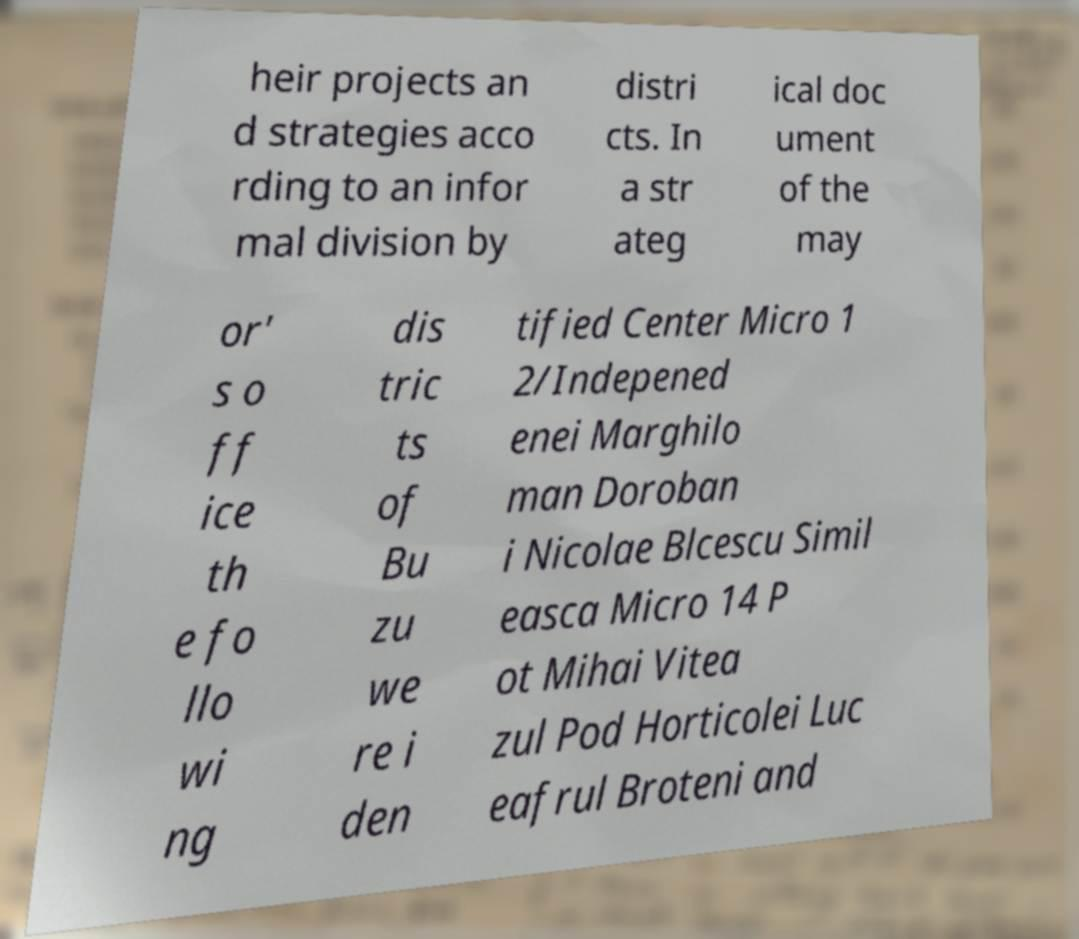Can you read and provide the text displayed in the image?This photo seems to have some interesting text. Can you extract and type it out for me? heir projects an d strategies acco rding to an infor mal division by distri cts. In a str ateg ical doc ument of the may or' s o ff ice th e fo llo wi ng dis tric ts of Bu zu we re i den tified Center Micro 1 2/Indepened enei Marghilo man Doroban i Nicolae Blcescu Simil easca Micro 14 P ot Mihai Vitea zul Pod Horticolei Luc eafrul Broteni and 